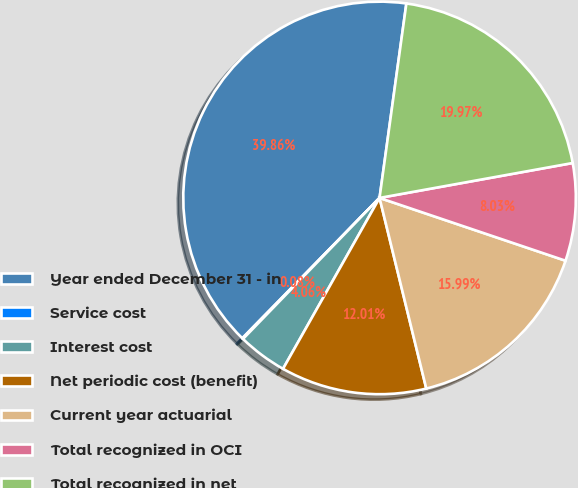Convert chart to OTSL. <chart><loc_0><loc_0><loc_500><loc_500><pie_chart><fcel>Year ended December 31 - in<fcel>Service cost<fcel>Interest cost<fcel>Net periodic cost (benefit)<fcel>Current year actuarial<fcel>Total recognized in OCI<fcel>Total recognized in net<nl><fcel>39.86%<fcel>0.08%<fcel>4.06%<fcel>12.01%<fcel>15.99%<fcel>8.03%<fcel>19.97%<nl></chart> 